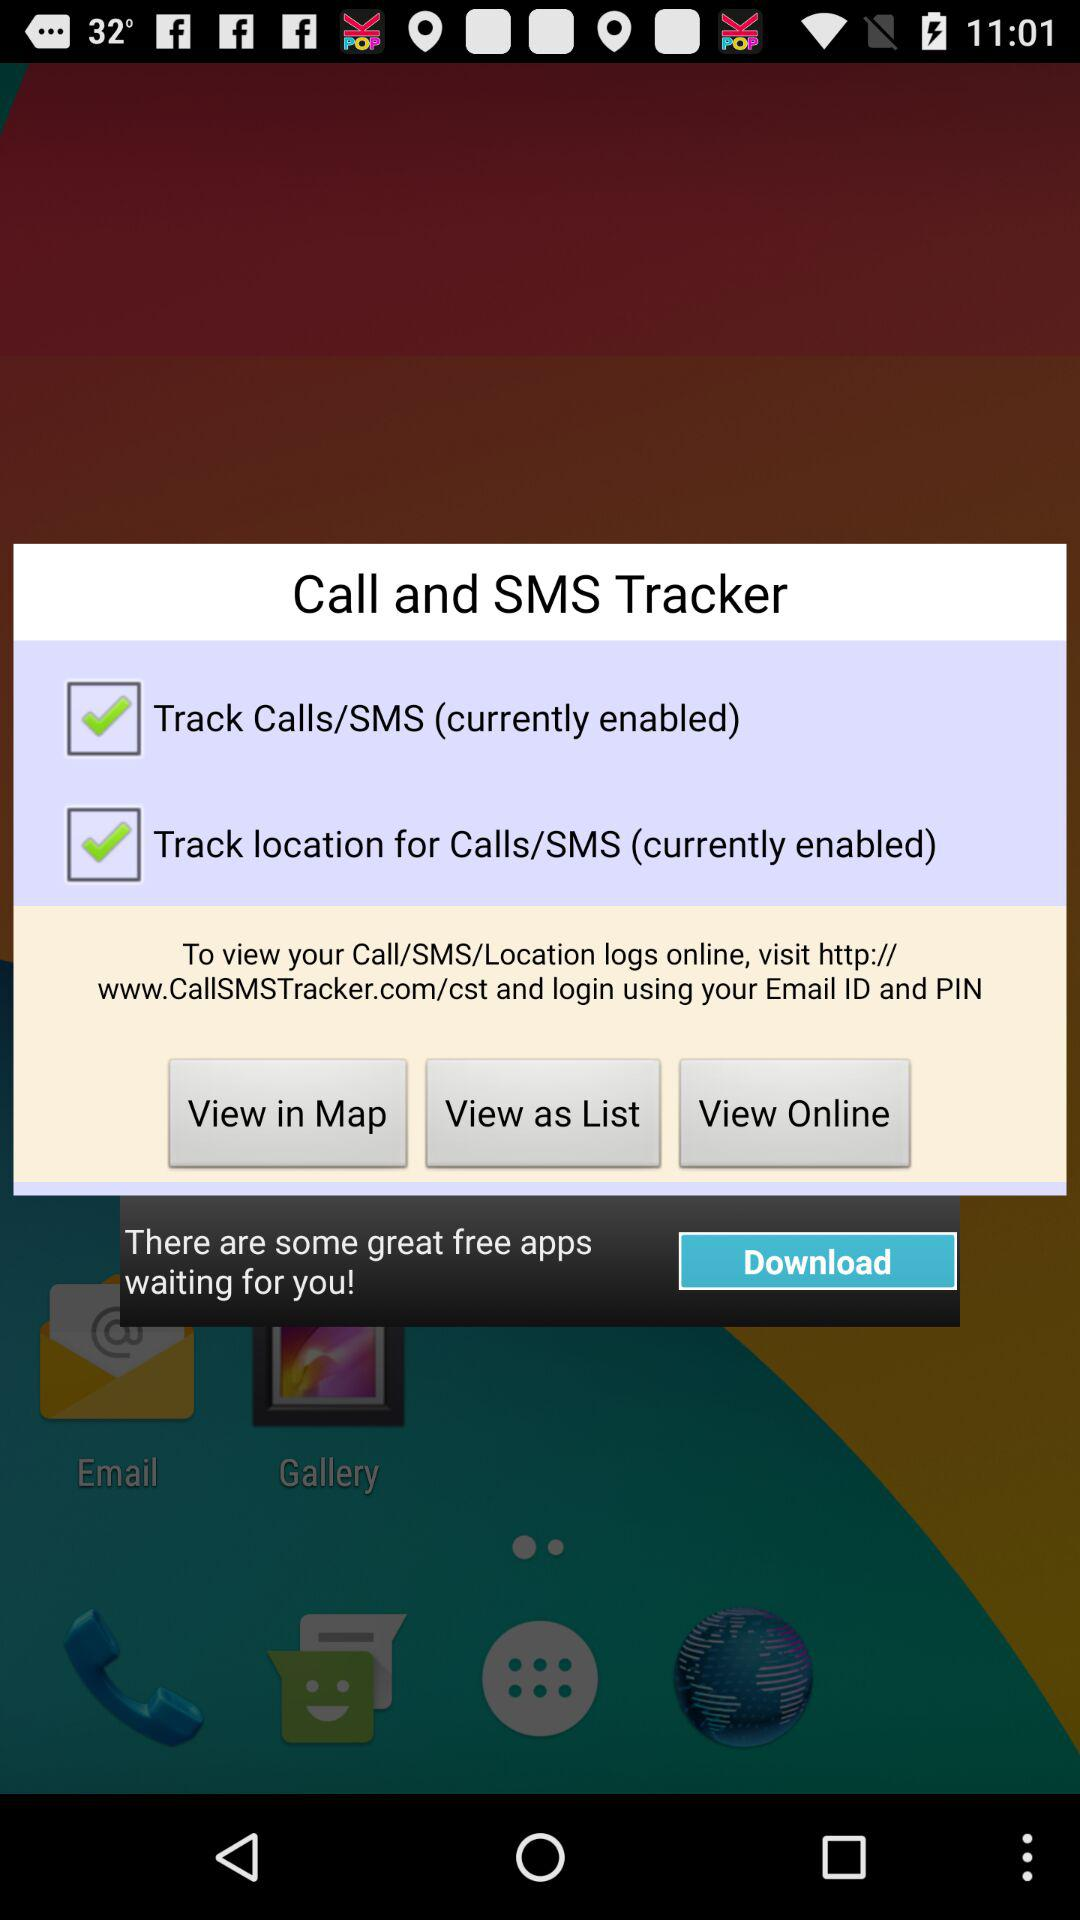Which view is selected?
When the provided information is insufficient, respond with <no answer>. <no answer> 